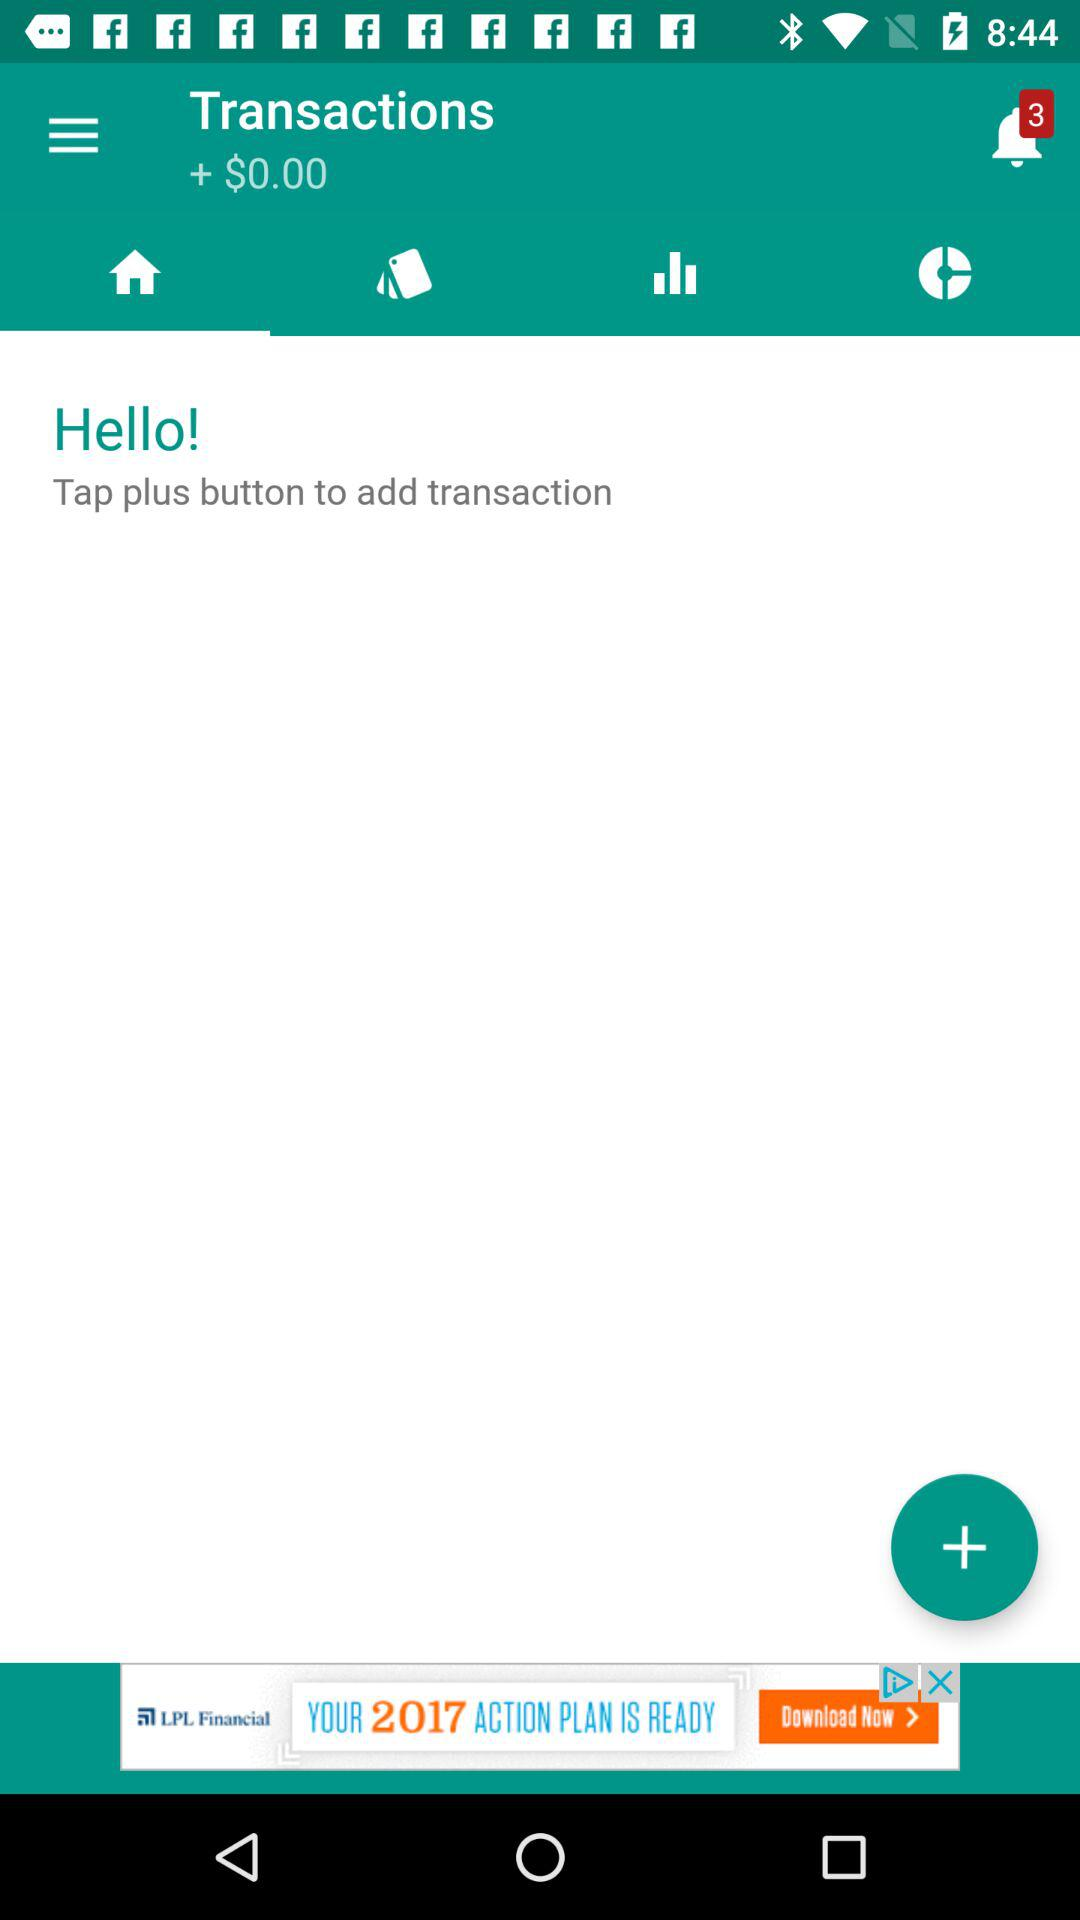What currency is shown here? The currency shown here is "$". 